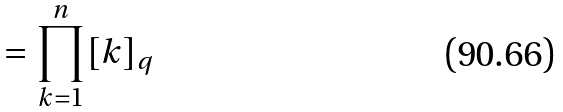<formula> <loc_0><loc_0><loc_500><loc_500>= \prod _ { k = 1 } ^ { n } [ k ] _ { q }</formula> 